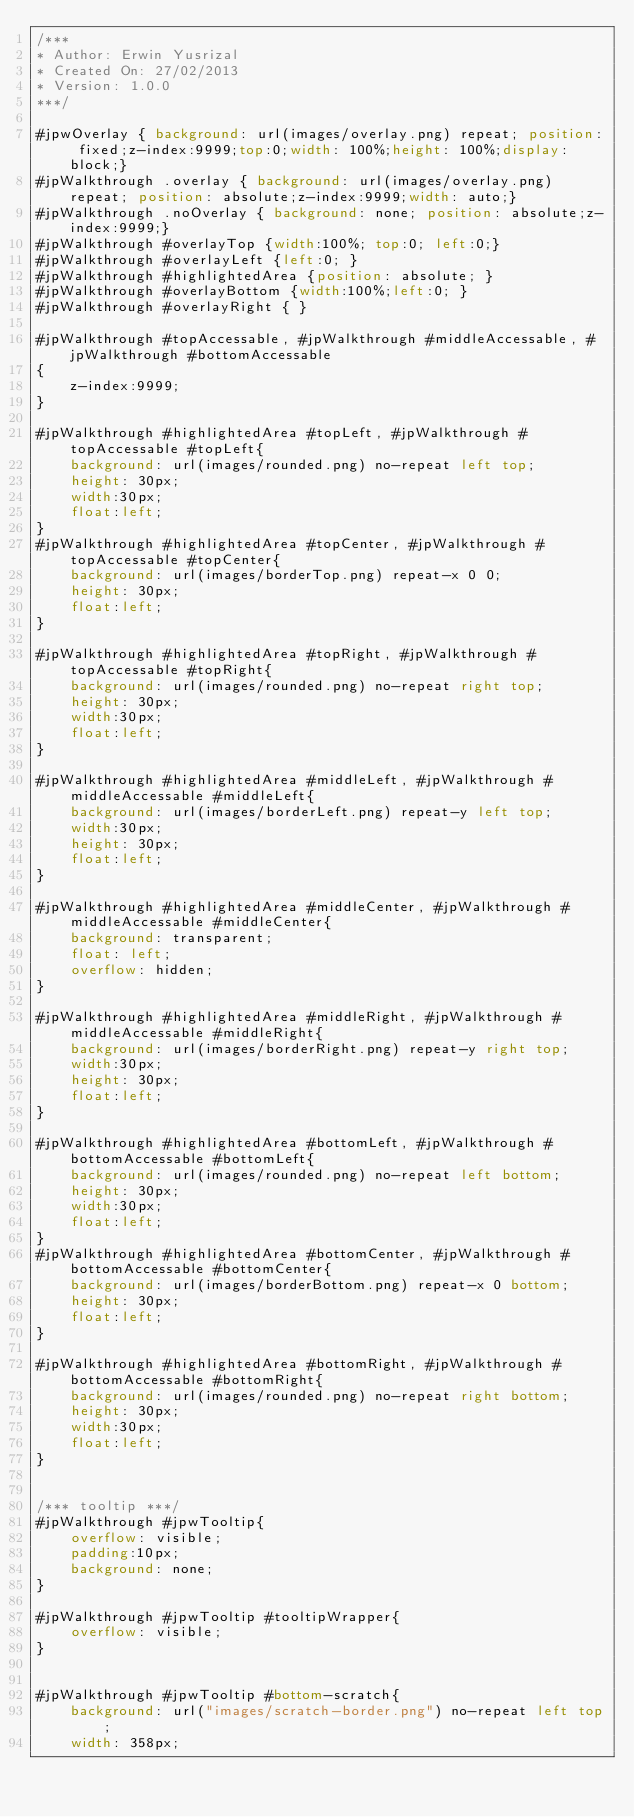Convert code to text. <code><loc_0><loc_0><loc_500><loc_500><_CSS_>/***
* Author: Erwin Yusrizal
* Created On: 27/02/2013
* Version: 1.0.0
***/

#jpwOverlay { background: url(images/overlay.png) repeat; position: fixed;z-index:9999;top:0;width: 100%;height: 100%;display: block;}
#jpWalkthrough .overlay { background: url(images/overlay.png) repeat; position: absolute;z-index:9999;width: auto;}
#jpWalkthrough .noOverlay { background: none; position: absolute;z-index:9999;}
#jpWalkthrough #overlayTop {width:100%; top:0; left:0;}
#jpWalkthrough #overlayLeft {left:0; }
#jpWalkthrough #highlightedArea {position: absolute; }
#jpWalkthrough #overlayBottom {width:100%;left:0; }
#jpWalkthrough #overlayRight { }

#jpWalkthrough #topAccessable, #jpWalkthrough #middleAccessable, #jpWalkthrough #bottomAccessable
{
    z-index:9999;
}

#jpWalkthrough #highlightedArea #topLeft, #jpWalkthrough #topAccessable #topLeft{
    background: url(images/rounded.png) no-repeat left top;
    height: 30px;
    width:30px;
    float:left;
}
#jpWalkthrough #highlightedArea #topCenter, #jpWalkthrough #topAccessable #topCenter{
    background: url(images/borderTop.png) repeat-x 0 0;
    height: 30px;
    float:left;
}

#jpWalkthrough #highlightedArea #topRight, #jpWalkthrough #topAccessable #topRight{
    background: url(images/rounded.png) no-repeat right top;
    height: 30px;
    width:30px;
    float:left;
}

#jpWalkthrough #highlightedArea #middleLeft, #jpWalkthrough #middleAccessable #middleLeft{
    background: url(images/borderLeft.png) repeat-y left top;
    width:30px;
    height: 30px;
    float:left;
}

#jpWalkthrough #highlightedArea #middleCenter, #jpWalkthrough #middleAccessable #middleCenter{
    background: transparent;
    float: left;
    overflow: hidden;
}

#jpWalkthrough #highlightedArea #middleRight, #jpWalkthrough #middleAccessable #middleRight{
    background: url(images/borderRight.png) repeat-y right top;
    width:30px;
    height: 30px;
    float:left;
}

#jpWalkthrough #highlightedArea #bottomLeft, #jpWalkthrough #bottomAccessable #bottomLeft{
    background: url(images/rounded.png) no-repeat left bottom;
    height: 30px;
    width:30px;
    float:left;
}
#jpWalkthrough #highlightedArea #bottomCenter, #jpWalkthrough #bottomAccessable #bottomCenter{
    background: url(images/borderBottom.png) repeat-x 0 bottom;
    height: 30px;
    float:left;
}

#jpWalkthrough #highlightedArea #bottomRight, #jpWalkthrough #bottomAccessable #bottomRight{
    background: url(images/rounded.png) no-repeat right bottom;
    height: 30px;
    width:30px;
    float:left;
}


/*** tooltip ***/
#jpWalkthrough #jpwTooltip{    
    overflow: visible;
    padding:10px;
    background: none;
}

#jpWalkthrough #jpwTooltip #tooltipWrapper{
    overflow: visible;
}


#jpWalkthrough #jpwTooltip #bottom-scratch{
    background: url("images/scratch-border.png") no-repeat left top;
    width: 358px;</code> 